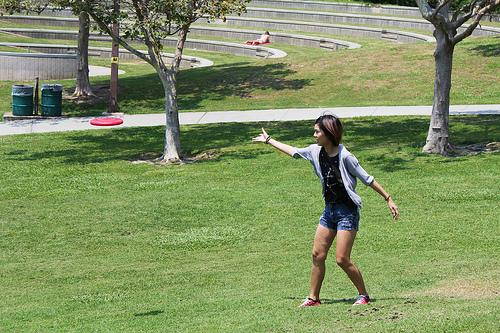Mention the most significant objects and actions present in the image. A woman in casual attire is engaged in playing with a red frisbee in a park, featuring trees, grass, and stone benches. Envision the scene in the image and describe it while emphasizing the woman's action. Picture a woman with short hair and casual clothes, smiling as she throws a frisbee, surrounded by the beauty and leisure of a park setting. Detail the image focusing on the action of the woman and aspects of the park she is in. The woman with short hair and fashionable clothing is joyfully throwing a red frisbee, immersed in a welcoming green park with stone amphitheater-style benches. Describe the image with a focus on the woman and her outfit and mention the action taking place. A short-haired woman wearing a light grey shirt, distressed blue jean shorts, and a bracelet is enjoying herself by throwing a frisbee in a park. Imagine a scene in a park and describe the action involving a woman and her surroundings. In a picturesque park, a casually-dressed woman with short hair confidently throws a frisbee across the lush grass, amidst an environment of trees, and stone benches. Provide a brief overview of the most prominent features in the image. A woman is throwing a frisbee in a park with grassy area and stone benches, she's wearing a light grey shirt, and blue jean shorts. Using descriptive language, detail the primary focus of the image and its setting. A young, stylish woman gleefully tosses a vibrant red frisbee amid a verdant park with lush grass, flourishing trees, and charming stone benches. Describe the woman's appearance and her surroundings in the image. The woman has short hair, light skin, and wears a grey cardigan, blue jean shorts, and a bracelet. She is in a park with grass, trees, and stone benches. Summarize the main elements and action in the image in one sentence. A woman wearing a grey cardigan and blue jean shorts happily throws a red frisbee in a green park with stone benches. Mention the most important action taking place in the image. The main action in the image is a woman in the park, throwing a red frisbee. 